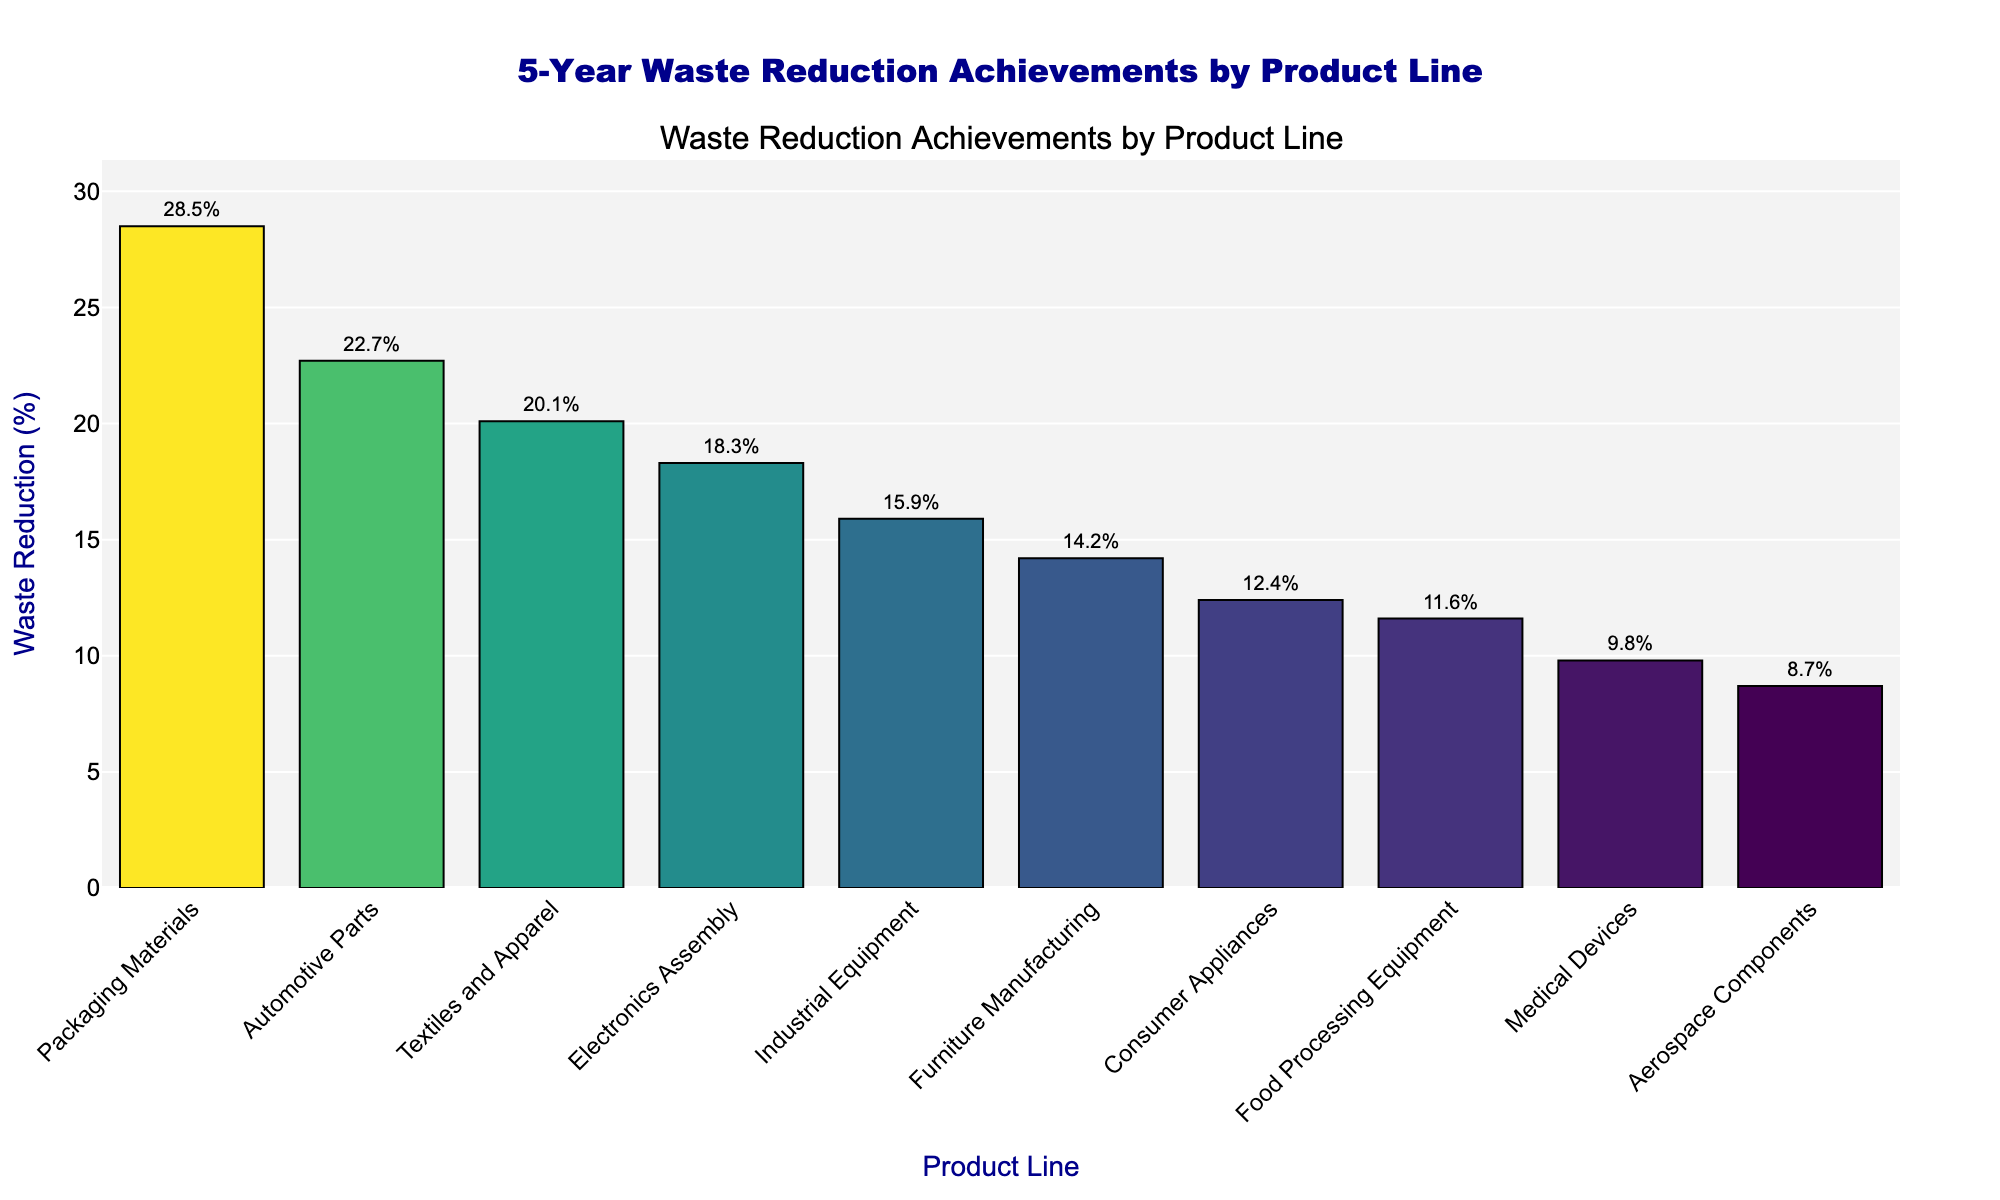Which product line has the highest waste reduction percentage? By observing the height of the bars, the bar representing Packaging Materials is the tallest, indicating the highest waste reduction percentage.
Answer: Packaging Materials Which product line has the lowest waste reduction percentage? By observing the height of the bars, the bar representing Aerospace Components is the shortest, indicating the lowest waste reduction percentage.
Answer: Aerospace Components What is the difference in waste reduction percentage between the Automotive Parts and Food Processing Equipment product lines? The waste reduction for Automotive Parts is 22.7%, and for Food Processing Equipment, it is 11.6%. Subtracting these, 22.7% - 11.6% = 11.1%.
Answer: 11.1% How many product lines achieved more than 20% waste reduction? From the visual data, the product lines with more than 20% waste reduction are Automotive Parts, Packaging Materials, and Textiles and Apparel. Counting these, there are 3.
Answer: 3 What is the average waste reduction percentage for all product lines shown? The waste reduction percentages are: 18.3, 22.7, 15.9, 12.4, 9.8, 28.5, 14.2, 20.1, 11.6, and 8.7. Summing these gives 162.2. There are 10 data points, so the average is 162.2/10 = 16.22%.
Answer: 16.22% Does the Electronics Assembly product line have a waste reduction percentage greater than the median waste reduction percentage of all product lines? The waste reduction percentages are: 18.3, 22.7, 15.9, 12.4, 9.8, 28.5, 14.2, 20.1, 11.6, and 8.7. Ordering these, the median is the average of the 5th and 6th values: (14.2 + 15.9) / 2 = 15.05%. The Electronics Assembly has 18.3%, which is greater than 15.05%.
Answer: Yes What is the sum of waste reductions for the Consumer Appliances and Medical Devices product lines? The waste reduction percentages are 12.4% for Consumer Appliances and 9.8% for Medical Devices. Summing these, 12.4 + 9.8 = 22.2%.
Answer: 22.2% Which product line has a waste reduction percentage closest to the average waste reduction percentage of all product lines? The average waste reduction percentage is 16.22%. The waste reductions are: 18.3, 22.7, 15.9, 12.4, 9.8, 28.5, 14.2, 20.1, 11.6, and 8.7. Calculating the absolute differences from 16.22%, the closest value is 15.9% (Industrial Equipment).
Answer: Industrial Equipment What is the range of waste reduction percentages among all product lines shown? The maximum waste reduction percentage is 28.5% (Packaging Materials) and the minimum is 8.7% (Aerospace Components). Subtracting these, 28.5% - 8.7% = 19.8%.
Answer: 19.8% 